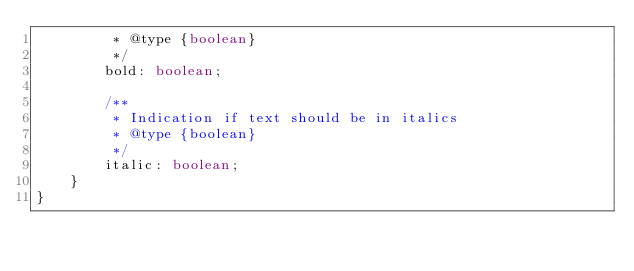Convert code to text. <code><loc_0><loc_0><loc_500><loc_500><_TypeScript_>         * @type {boolean}
         */
        bold: boolean;
        
        /**
         * Indication if text should be in italics
         * @type {boolean}
         */
        italic: boolean;
    }
}
</code> 